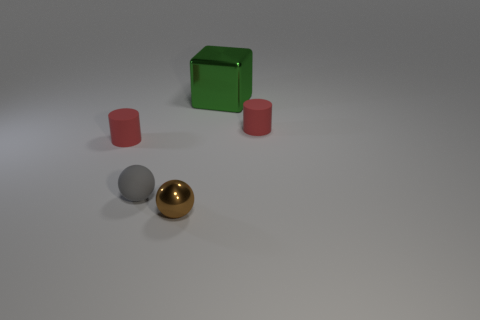Is there a sphere that has the same material as the green object?
Give a very brief answer. Yes. Is there a red matte object in front of the tiny red object behind the red cylinder that is to the left of the small matte sphere?
Your answer should be very brief. Yes. Are there any small rubber balls in front of the big metallic object?
Your answer should be very brief. Yes. Are there any metal cylinders of the same color as the large object?
Ensure brevity in your answer.  No. How many big objects are brown shiny things or cyan metallic cylinders?
Give a very brief answer. 0. Do the tiny cylinder that is left of the small metal ball and the gray thing have the same material?
Ensure brevity in your answer.  Yes. There is a matte thing in front of the red matte object in front of the red matte cylinder that is right of the small brown metallic ball; what is its shape?
Provide a short and direct response. Sphere. What number of red things are tiny balls or small cylinders?
Give a very brief answer. 2. Are there an equal number of gray rubber balls that are left of the shiny block and rubber cylinders that are left of the small gray matte sphere?
Provide a succinct answer. Yes. There is a shiny thing in front of the green metal block; is it the same shape as the small rubber object to the right of the small metallic thing?
Your response must be concise. No. 